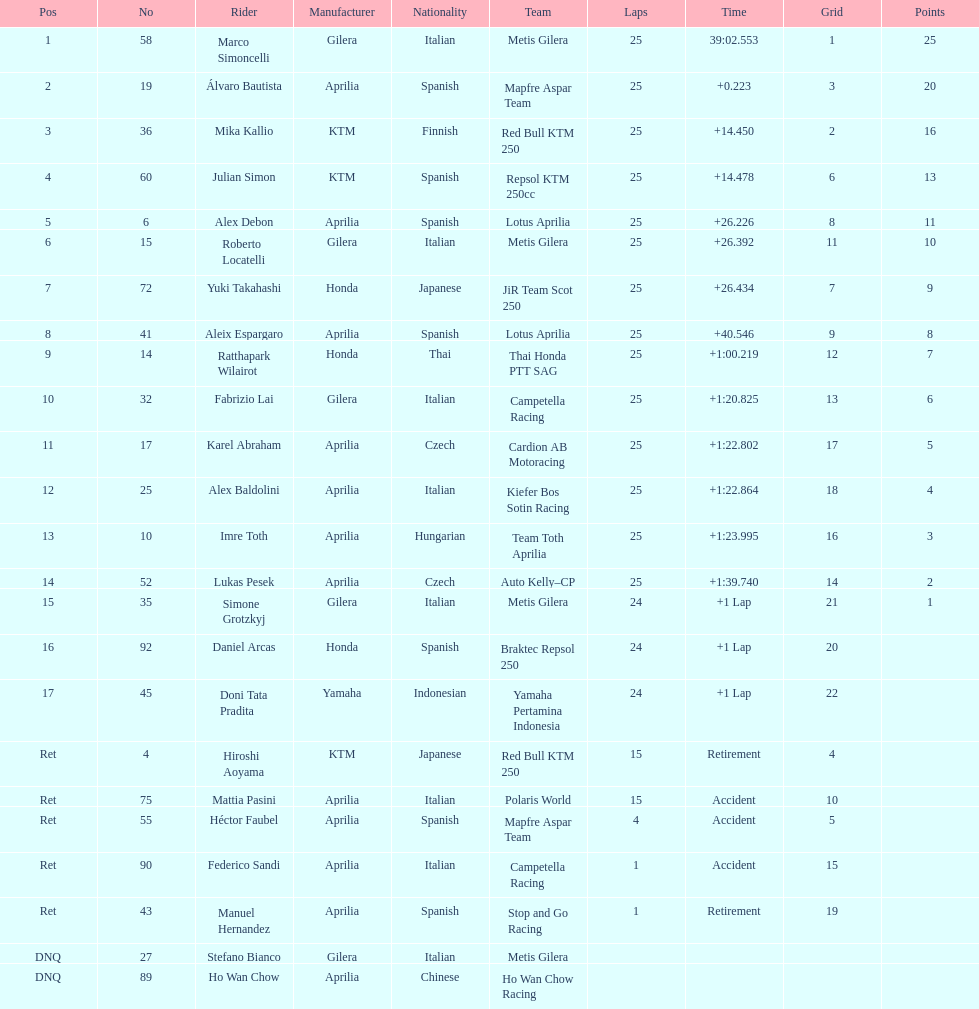The total amount of riders who did not qualify 2. 